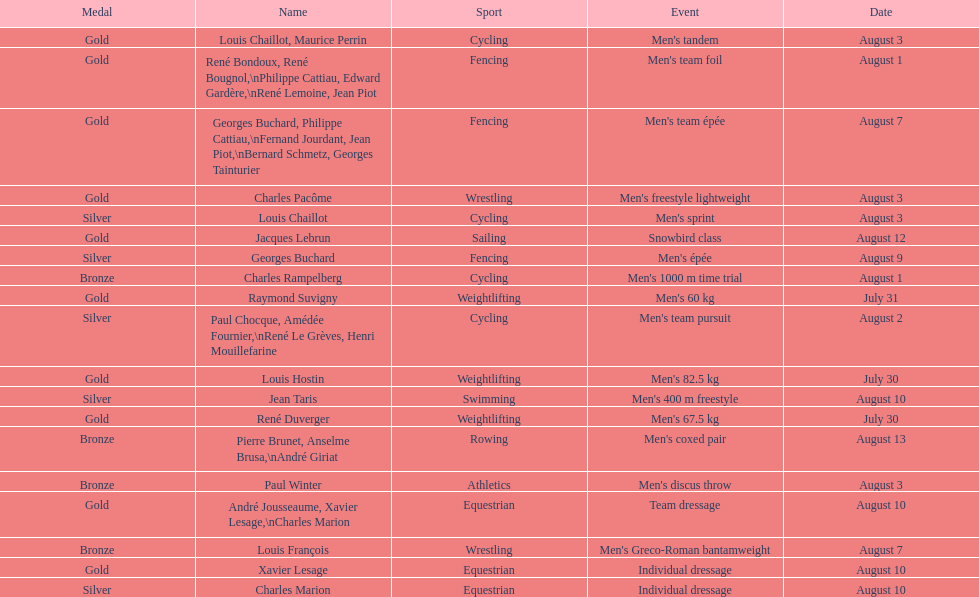What event is listed right before team dressage? Individual dressage. 